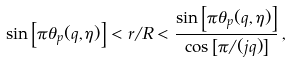Convert formula to latex. <formula><loc_0><loc_0><loc_500><loc_500>\sin \left [ \pi \theta _ { p } ( q , \eta ) \right ] < r / R < \frac { \sin \left [ \pi \theta _ { p } ( q , \eta ) \right ] } { \cos \left [ \pi / ( j q ) \right ] } \, ,</formula> 